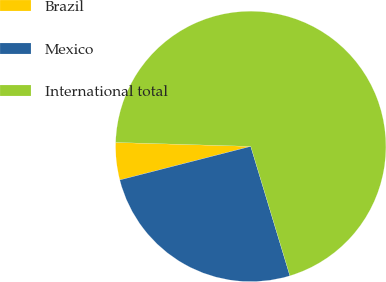Convert chart. <chart><loc_0><loc_0><loc_500><loc_500><pie_chart><fcel>Brazil<fcel>Mexico<fcel>International total<nl><fcel>4.46%<fcel>25.68%<fcel>69.85%<nl></chart> 